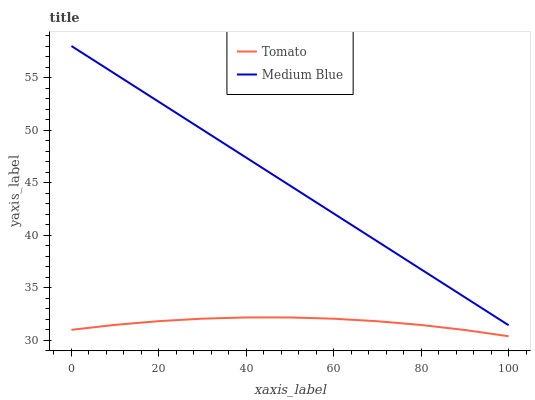Does Tomato have the minimum area under the curve?
Answer yes or no. Yes. Does Medium Blue have the maximum area under the curve?
Answer yes or no. Yes. Does Medium Blue have the minimum area under the curve?
Answer yes or no. No. Is Medium Blue the smoothest?
Answer yes or no. Yes. Is Tomato the roughest?
Answer yes or no. Yes. Is Medium Blue the roughest?
Answer yes or no. No. Does Medium Blue have the lowest value?
Answer yes or no. No. Does Medium Blue have the highest value?
Answer yes or no. Yes. Is Tomato less than Medium Blue?
Answer yes or no. Yes. Is Medium Blue greater than Tomato?
Answer yes or no. Yes. Does Tomato intersect Medium Blue?
Answer yes or no. No. 